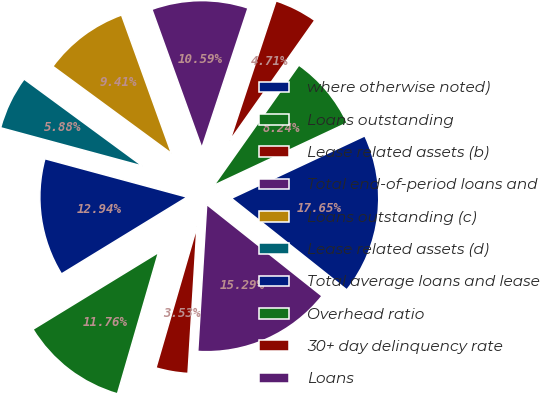<chart> <loc_0><loc_0><loc_500><loc_500><pie_chart><fcel>where otherwise noted)<fcel>Loans outstanding<fcel>Lease related assets (b)<fcel>Total end-of-period loans and<fcel>Loans outstanding (c)<fcel>Lease related assets (d)<fcel>Total average loans and lease<fcel>Overhead ratio<fcel>30+ day delinquency rate<fcel>Loans<nl><fcel>17.65%<fcel>8.24%<fcel>4.71%<fcel>10.59%<fcel>9.41%<fcel>5.88%<fcel>12.94%<fcel>11.76%<fcel>3.53%<fcel>15.29%<nl></chart> 